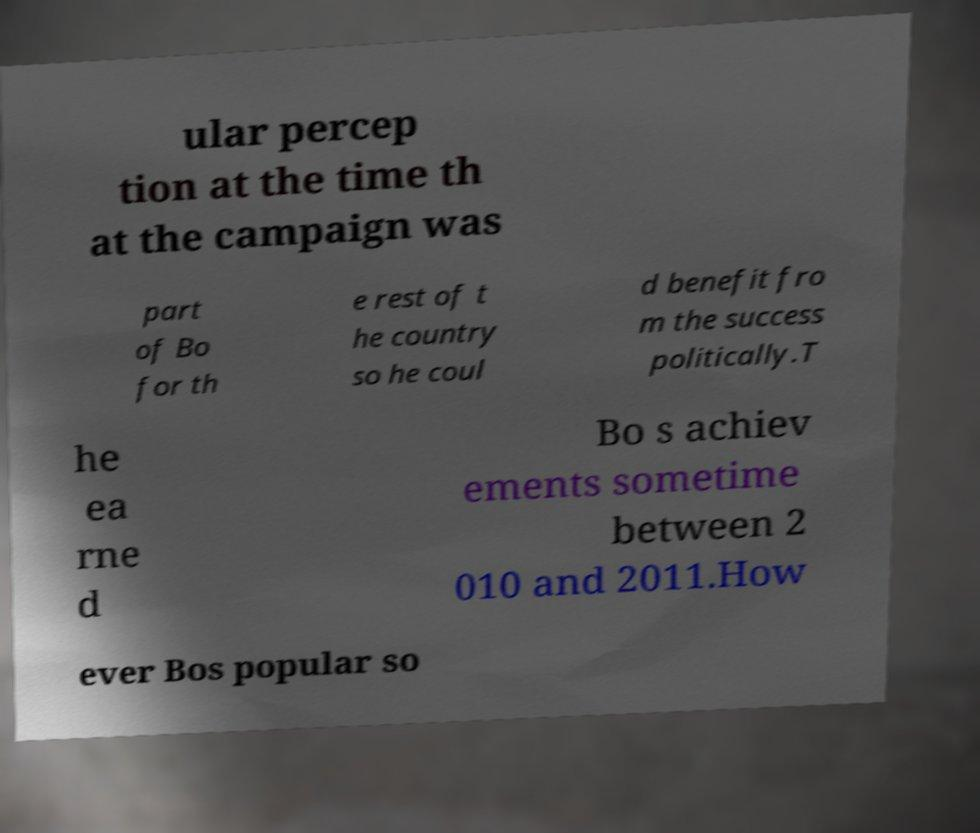For documentation purposes, I need the text within this image transcribed. Could you provide that? ular percep tion at the time th at the campaign was part of Bo for th e rest of t he country so he coul d benefit fro m the success politically.T he ea rne d Bo s achiev ements sometime between 2 010 and 2011.How ever Bos popular so 